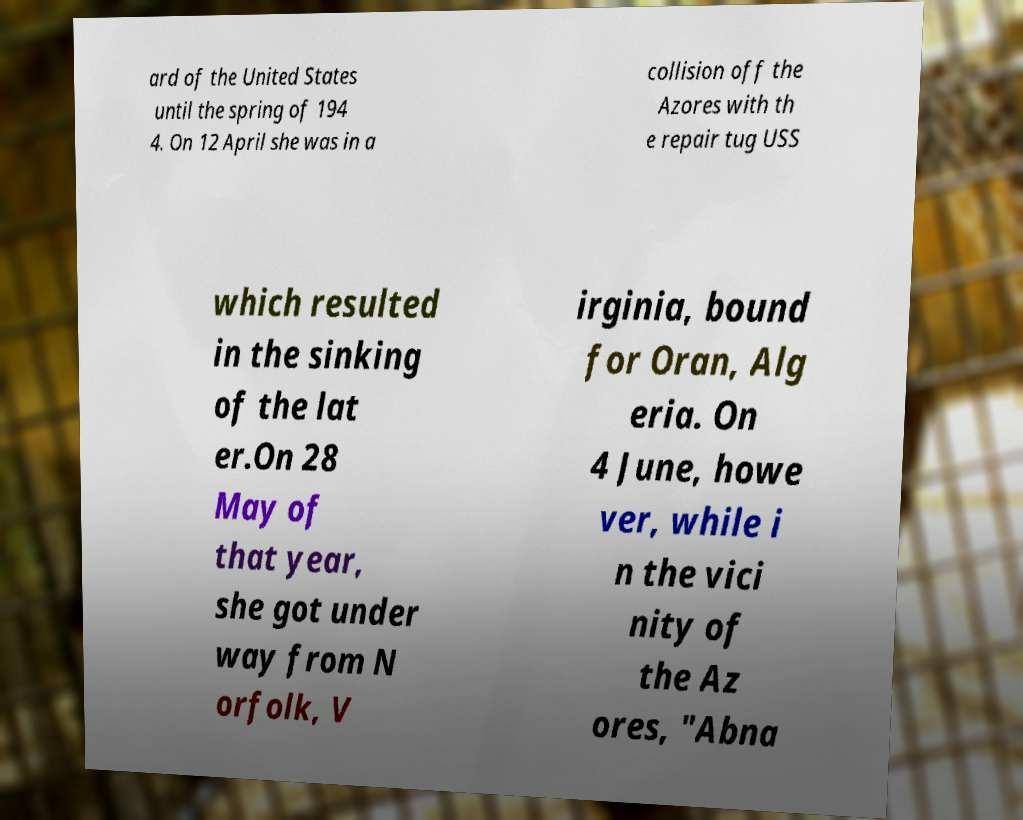I need the written content from this picture converted into text. Can you do that? ard of the United States until the spring of 194 4. On 12 April she was in a collision off the Azores with th e repair tug USS which resulted in the sinking of the lat er.On 28 May of that year, she got under way from N orfolk, V irginia, bound for Oran, Alg eria. On 4 June, howe ver, while i n the vici nity of the Az ores, "Abna 